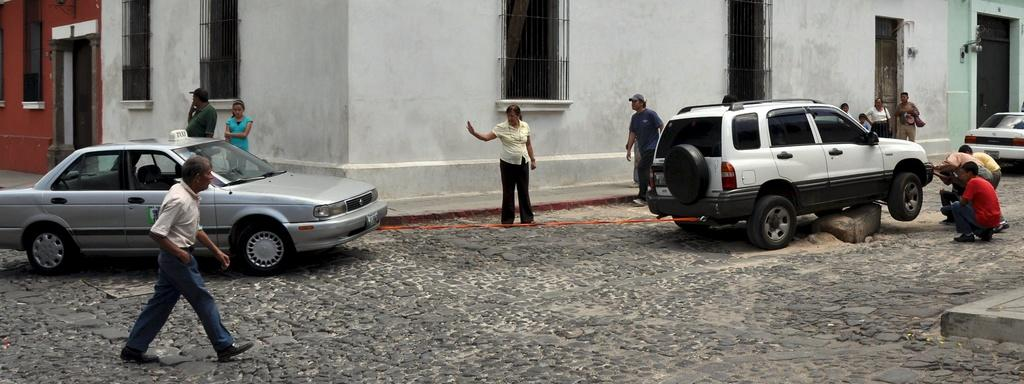What type of vehicles can be seen on the road in the image? There are cars on the road in the image. Can you describe the people visible in the image? There are people visible in the image. What can be seen in the background of the image? In the background, there is a wall, windows, and doors. What type of game is being played by the people in the image? There is no game being played by the people in the image. What is being served for dinner in the image? There is no dinner being served in the image. 